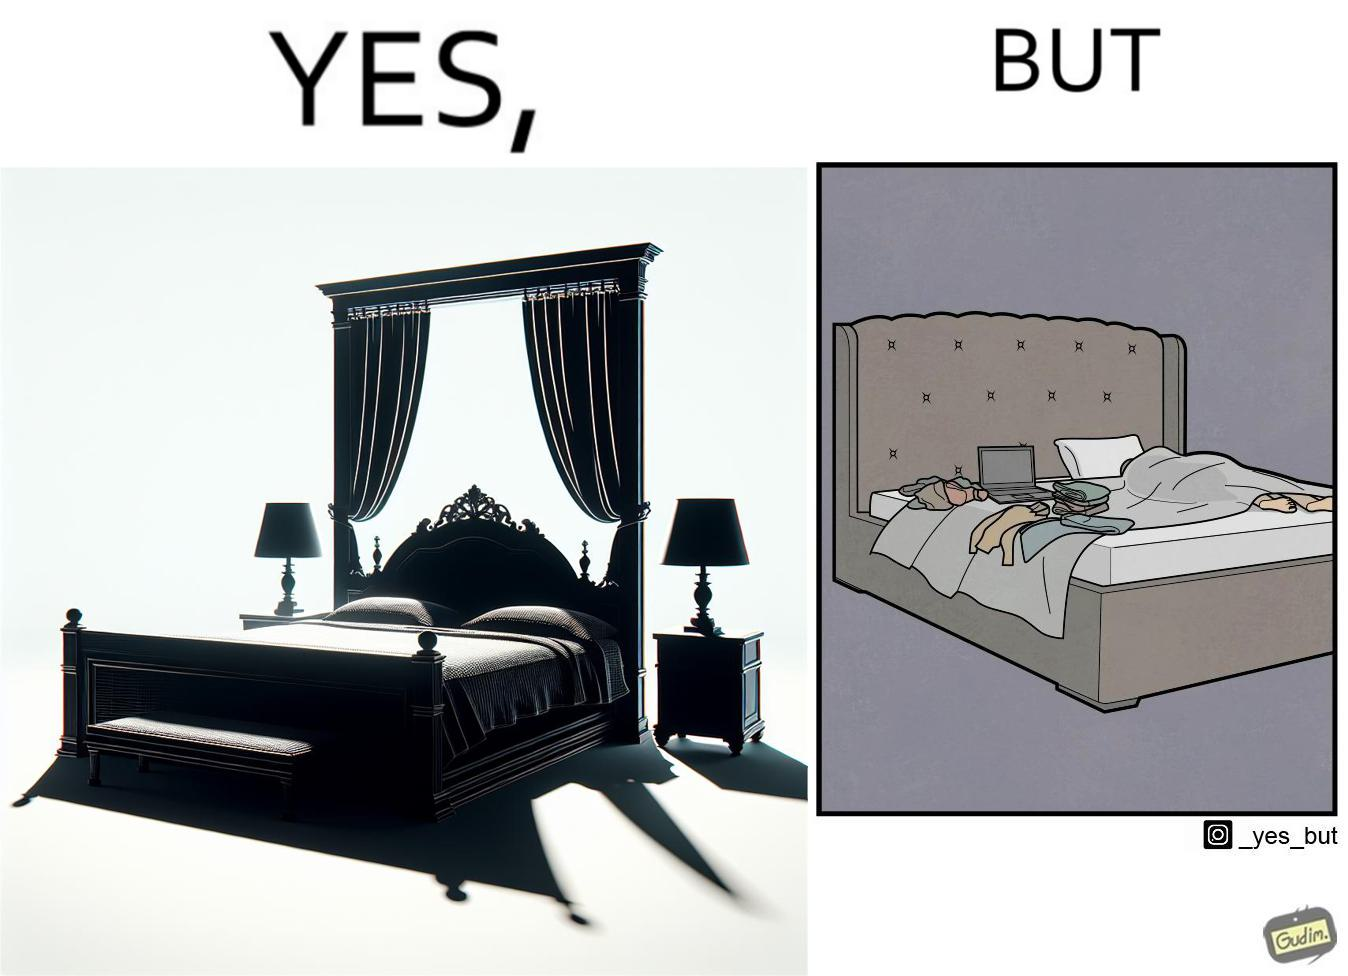What is shown in the left half versus the right half of this image? In the left part of the image: There is a bed of king size. In the right part of the image: There is a person sleeping with his material on its bed; 